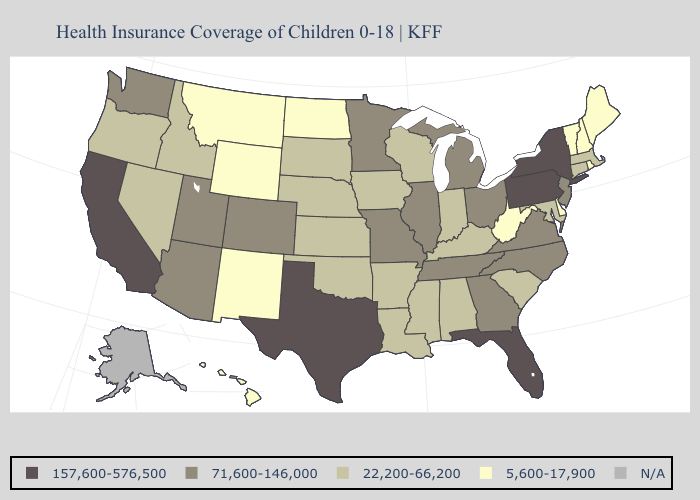Does Hawaii have the highest value in the West?
Give a very brief answer. No. Name the states that have a value in the range 22,200-66,200?
Keep it brief. Alabama, Arkansas, Connecticut, Idaho, Indiana, Iowa, Kansas, Kentucky, Louisiana, Maryland, Massachusetts, Mississippi, Nebraska, Nevada, Oklahoma, Oregon, South Carolina, South Dakota, Wisconsin. Name the states that have a value in the range N/A?
Give a very brief answer. Alaska. Name the states that have a value in the range 157,600-576,500?
Give a very brief answer. California, Florida, New York, Pennsylvania, Texas. What is the highest value in the MidWest ?
Keep it brief. 71,600-146,000. Name the states that have a value in the range N/A?
Concise answer only. Alaska. Does New Hampshire have the highest value in the USA?
Concise answer only. No. Is the legend a continuous bar?
Keep it brief. No. Does Arizona have the highest value in the West?
Keep it brief. No. What is the highest value in the MidWest ?
Give a very brief answer. 71,600-146,000. What is the highest value in states that border North Carolina?
Concise answer only. 71,600-146,000. Which states hav the highest value in the Northeast?
Be succinct. New York, Pennsylvania. What is the value of Wisconsin?
Give a very brief answer. 22,200-66,200. What is the value of California?
Quick response, please. 157,600-576,500. 